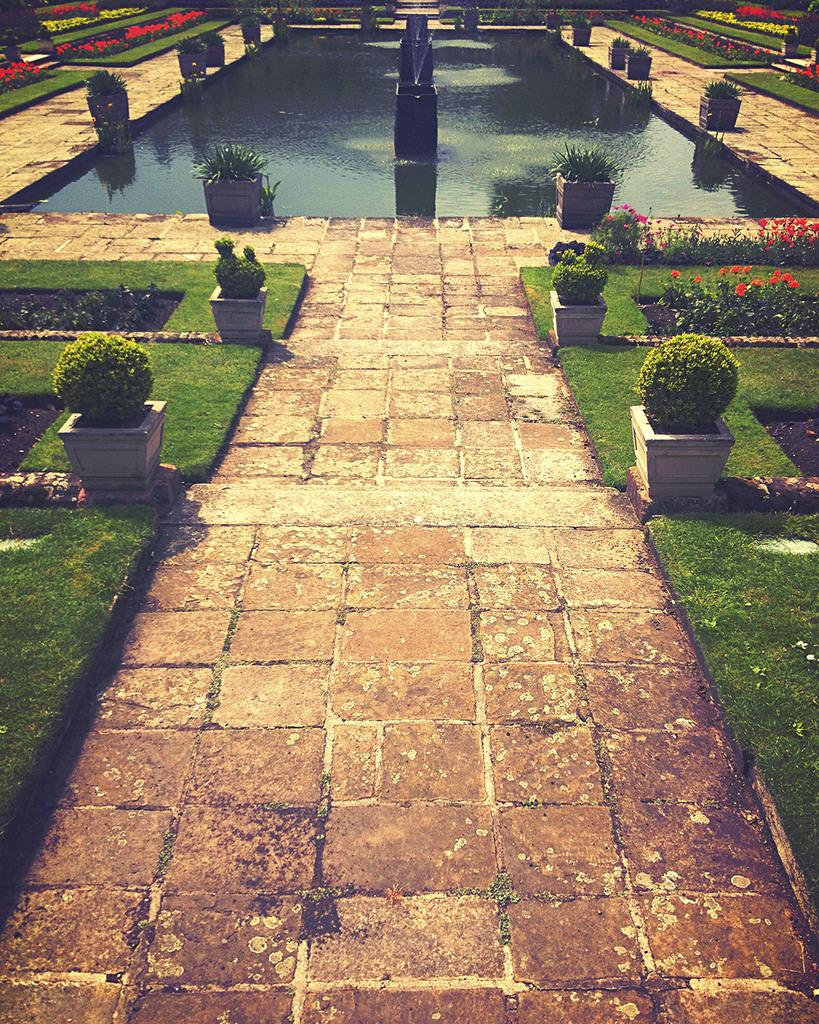What type of location is depicted in the image? The image depicts a park or a garden. What is one of the main features of the park or garden? The park or garden is decorated with grass. Are there any plants in the park or garden that are not directly in the ground? Yes, there are potted plants in the park or garden. What can be found in the center of the image? There is a water pond in the center of the image. What is a notable feature of the water pond? The water pond has a fountain. What is the purpose of the hen in the image? There is no hen present in the image. Can you hear the voice of the person in the image? There is no person in the image, so it is not possible to hear their voice. 